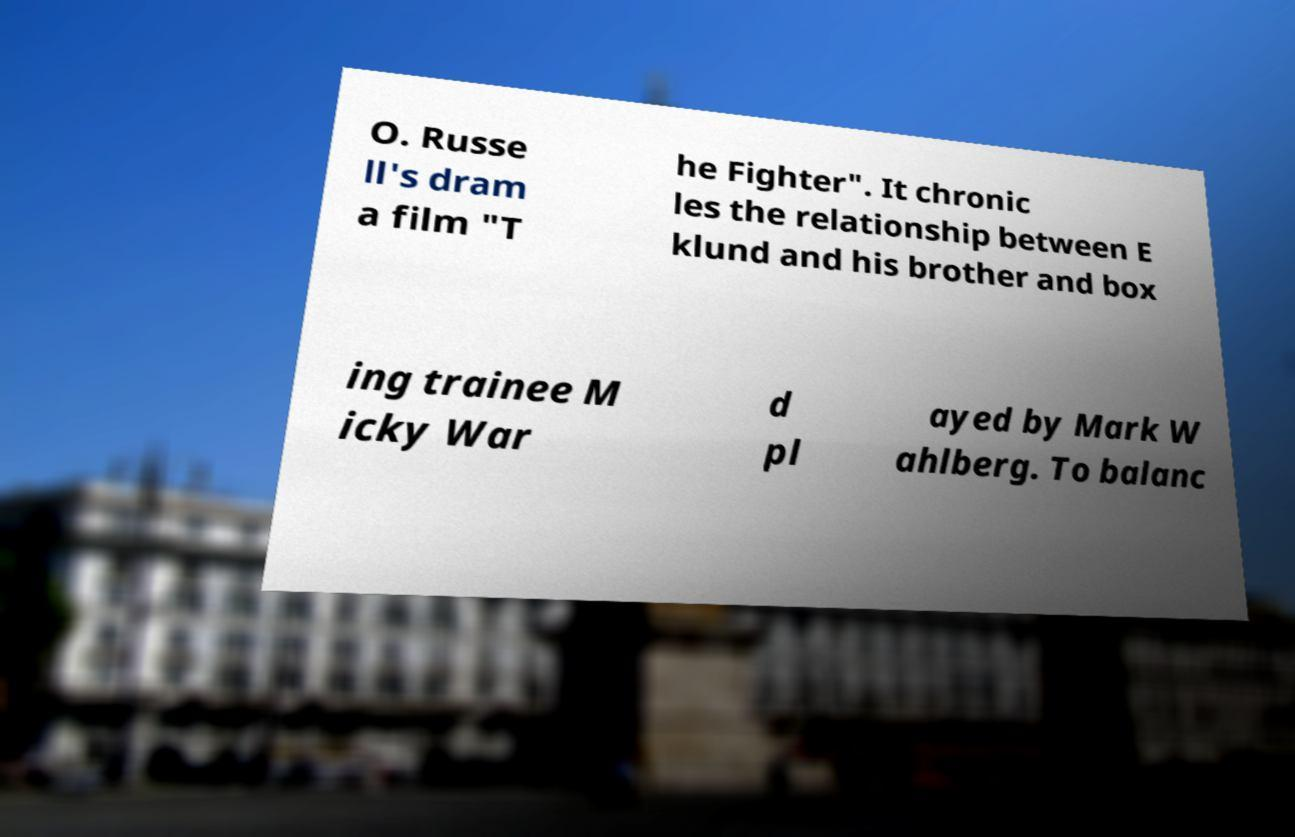Could you assist in decoding the text presented in this image and type it out clearly? O. Russe ll's dram a film "T he Fighter". It chronic les the relationship between E klund and his brother and box ing trainee M icky War d pl ayed by Mark W ahlberg. To balanc 